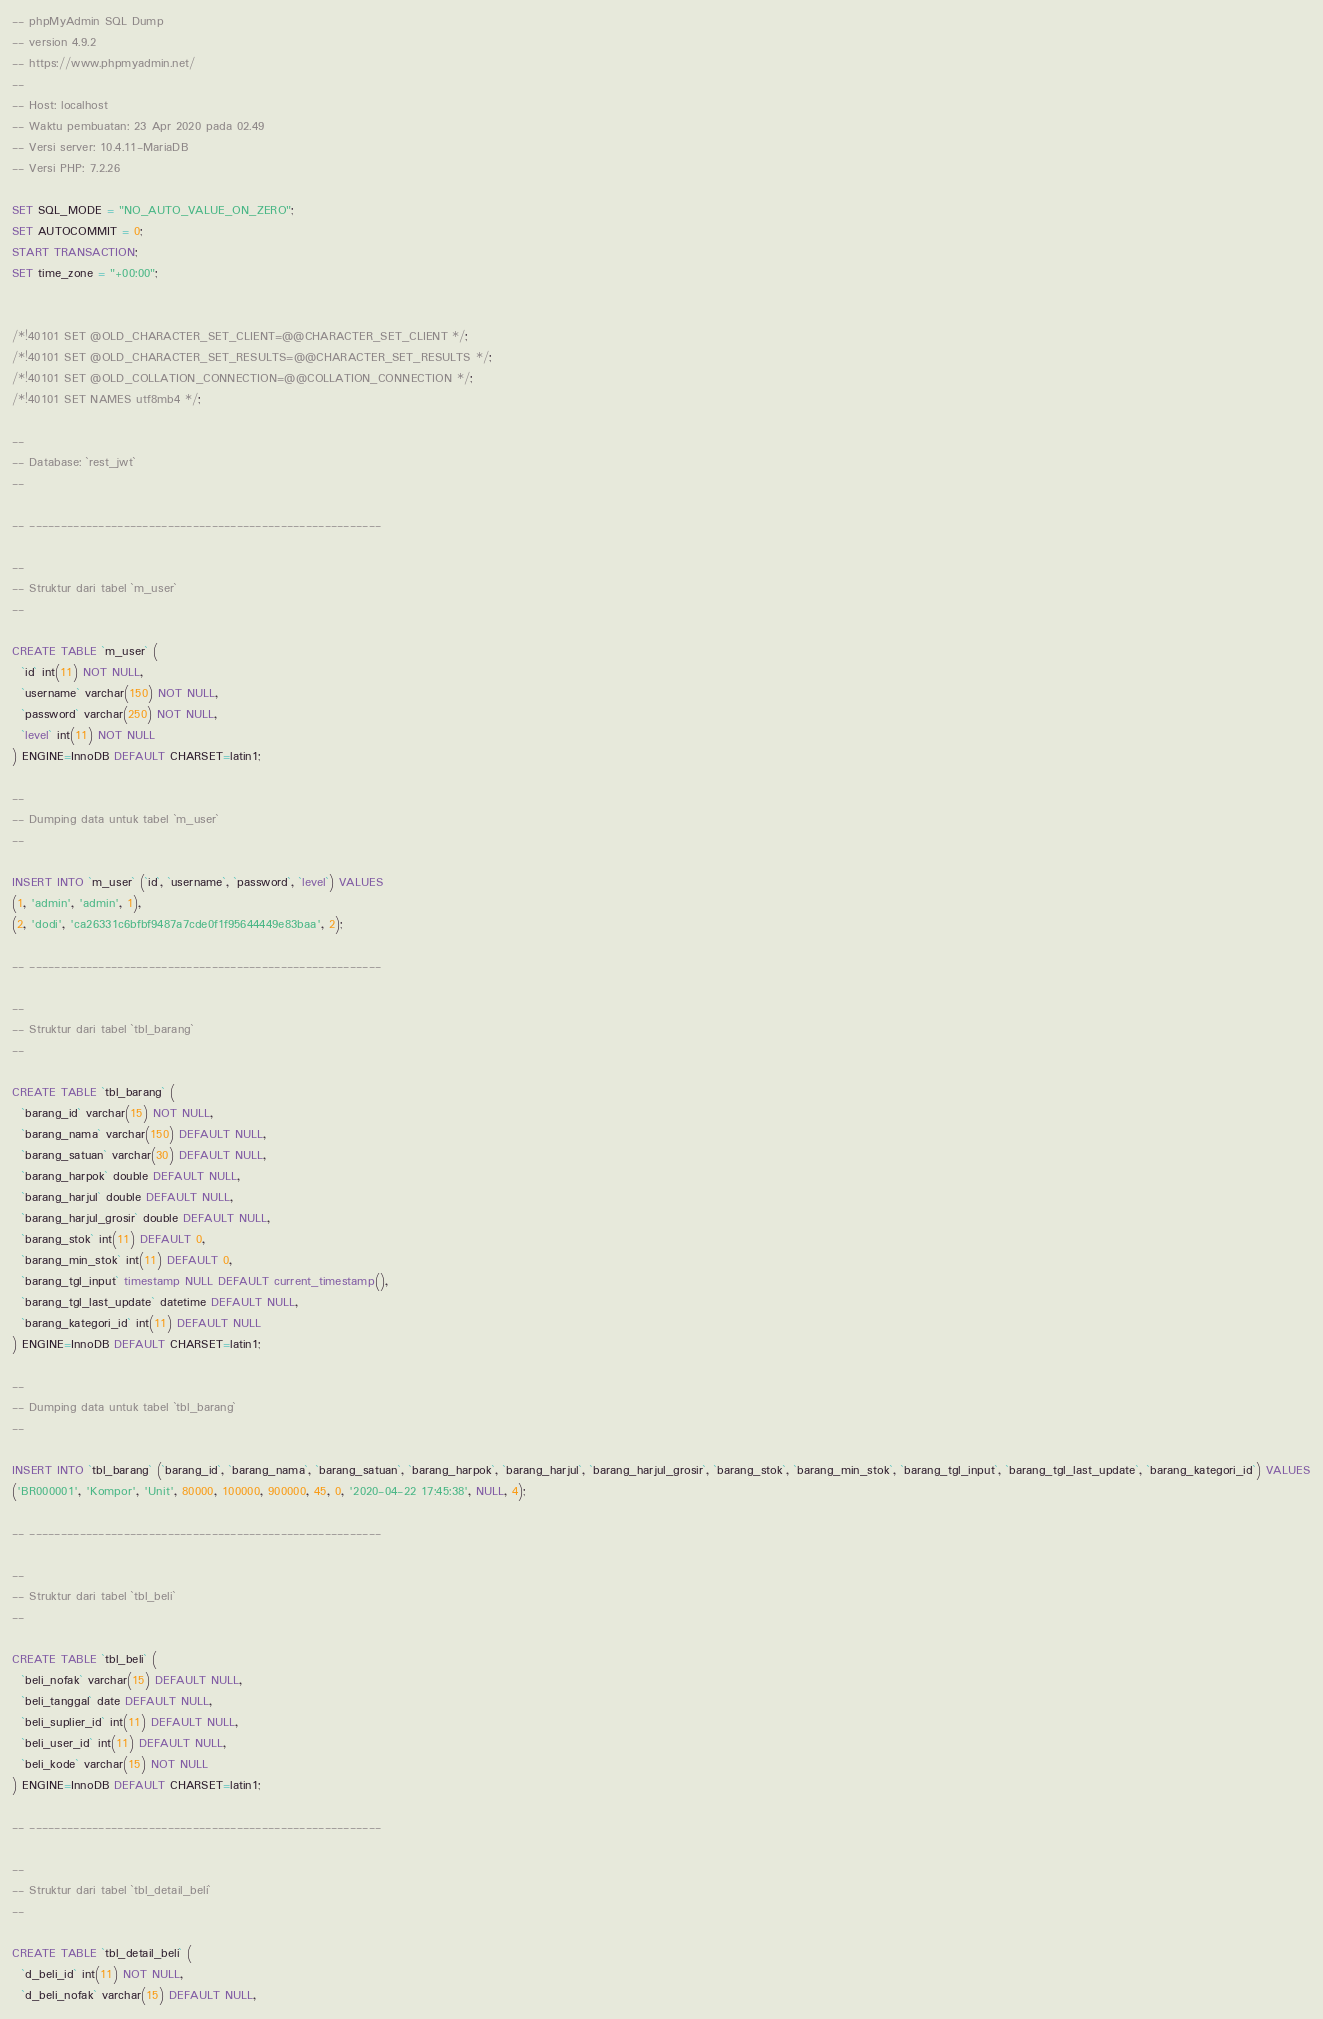Convert code to text. <code><loc_0><loc_0><loc_500><loc_500><_SQL_>-- phpMyAdmin SQL Dump
-- version 4.9.2
-- https://www.phpmyadmin.net/
--
-- Host: localhost
-- Waktu pembuatan: 23 Apr 2020 pada 02.49
-- Versi server: 10.4.11-MariaDB
-- Versi PHP: 7.2.26

SET SQL_MODE = "NO_AUTO_VALUE_ON_ZERO";
SET AUTOCOMMIT = 0;
START TRANSACTION;
SET time_zone = "+00:00";


/*!40101 SET @OLD_CHARACTER_SET_CLIENT=@@CHARACTER_SET_CLIENT */;
/*!40101 SET @OLD_CHARACTER_SET_RESULTS=@@CHARACTER_SET_RESULTS */;
/*!40101 SET @OLD_COLLATION_CONNECTION=@@COLLATION_CONNECTION */;
/*!40101 SET NAMES utf8mb4 */;

--
-- Database: `rest_jwt`
--

-- --------------------------------------------------------

--
-- Struktur dari tabel `m_user`
--

CREATE TABLE `m_user` (
  `id` int(11) NOT NULL,
  `username` varchar(150) NOT NULL,
  `password` varchar(250) NOT NULL,
  `level` int(11) NOT NULL
) ENGINE=InnoDB DEFAULT CHARSET=latin1;

--
-- Dumping data untuk tabel `m_user`
--

INSERT INTO `m_user` (`id`, `username`, `password`, `level`) VALUES
(1, 'admin', 'admin', 1),
(2, 'dodi', 'ca26331c6bfbf9487a7cde0f1f95644449e83baa', 2);

-- --------------------------------------------------------

--
-- Struktur dari tabel `tbl_barang`
--

CREATE TABLE `tbl_barang` (
  `barang_id` varchar(15) NOT NULL,
  `barang_nama` varchar(150) DEFAULT NULL,
  `barang_satuan` varchar(30) DEFAULT NULL,
  `barang_harpok` double DEFAULT NULL,
  `barang_harjul` double DEFAULT NULL,
  `barang_harjul_grosir` double DEFAULT NULL,
  `barang_stok` int(11) DEFAULT 0,
  `barang_min_stok` int(11) DEFAULT 0,
  `barang_tgl_input` timestamp NULL DEFAULT current_timestamp(),
  `barang_tgl_last_update` datetime DEFAULT NULL,
  `barang_kategori_id` int(11) DEFAULT NULL
) ENGINE=InnoDB DEFAULT CHARSET=latin1;

--
-- Dumping data untuk tabel `tbl_barang`
--

INSERT INTO `tbl_barang` (`barang_id`, `barang_nama`, `barang_satuan`, `barang_harpok`, `barang_harjul`, `barang_harjul_grosir`, `barang_stok`, `barang_min_stok`, `barang_tgl_input`, `barang_tgl_last_update`, `barang_kategori_id`) VALUES
('BR000001', 'Kompor', 'Unit', 80000, 100000, 900000, 45, 0, '2020-04-22 17:45:38', NULL, 4);

-- --------------------------------------------------------

--
-- Struktur dari tabel `tbl_beli`
--

CREATE TABLE `tbl_beli` (
  `beli_nofak` varchar(15) DEFAULT NULL,
  `beli_tanggal` date DEFAULT NULL,
  `beli_suplier_id` int(11) DEFAULT NULL,
  `beli_user_id` int(11) DEFAULT NULL,
  `beli_kode` varchar(15) NOT NULL
) ENGINE=InnoDB DEFAULT CHARSET=latin1;

-- --------------------------------------------------------

--
-- Struktur dari tabel `tbl_detail_beli`
--

CREATE TABLE `tbl_detail_beli` (
  `d_beli_id` int(11) NOT NULL,
  `d_beli_nofak` varchar(15) DEFAULT NULL,</code> 